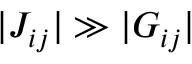Convert formula to latex. <formula><loc_0><loc_0><loc_500><loc_500>| J _ { i j } | \gg | G _ { i j } |</formula> 